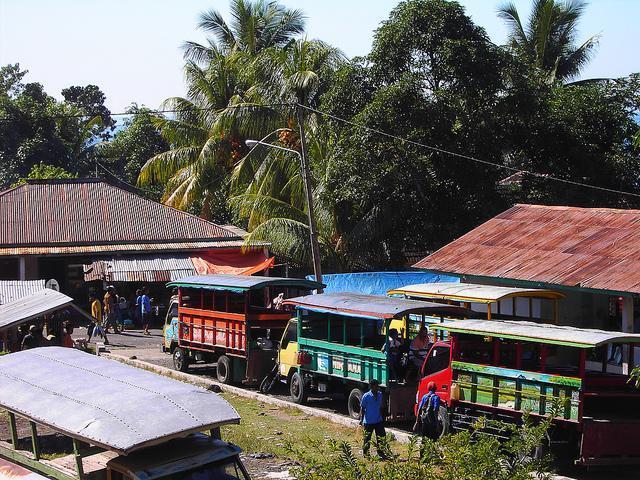How many buses are in the photo?
Give a very brief answer. 3. 